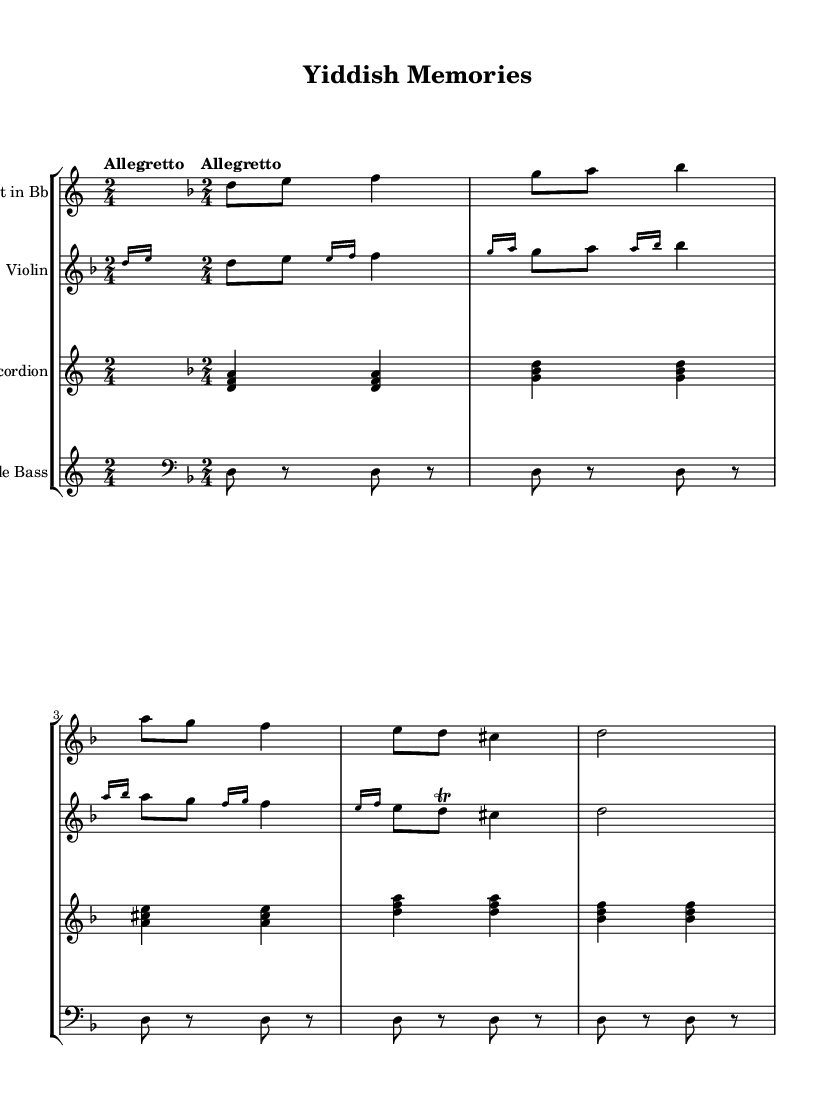What is the key signature of this music? The key signature indicates that the piece is in D minor, which has one flat (B flat). You can tell this by looking at the key signature displayed at the beginning of the score.
Answer: D minor What is the time signature of the piece? The time signature shown at the beginning of the score is 2/4, indicating that there are two beats in each measure, and each quarter note gets one beat. You can find this information directly beneath the key signature.
Answer: 2/4 What is the tempo marking for this piece? The tempo marking specified in the score is "Allegretto." This tempo marking suggests a moderately quick pace, and it is written on the first line of the music under the title.
Answer: Allegretto Which instruments are included in this arrangement? The score lists four instruments: Clarinet in Bb, Violin, Accordion, and Double Bass. These instruments are identified in the staff names, which are indicated on the left side of each staff group in the score.
Answer: Clarinet, Violin, Accordion, Double Bass What is the initial note for the clarinet in the first measure? The initial note for the clarinet in the first measure is D. This can be determined by examining the first note at the beginning of the clarinet staff, which corresponds to the D note on the staff.
Answer: D What type of music genre is this piece classified as? This piece is classified under Folk music, specifically Klezmer-influenced folk tunes from Eastern European Jewish communities. This classification can be inferred from the cultural context and instrumentation associated with the arrangement.
Answer: Folk 